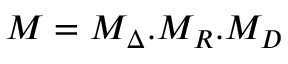<formula> <loc_0><loc_0><loc_500><loc_500>M = M _ { \Delta } . M _ { R } . M _ { D }</formula> 